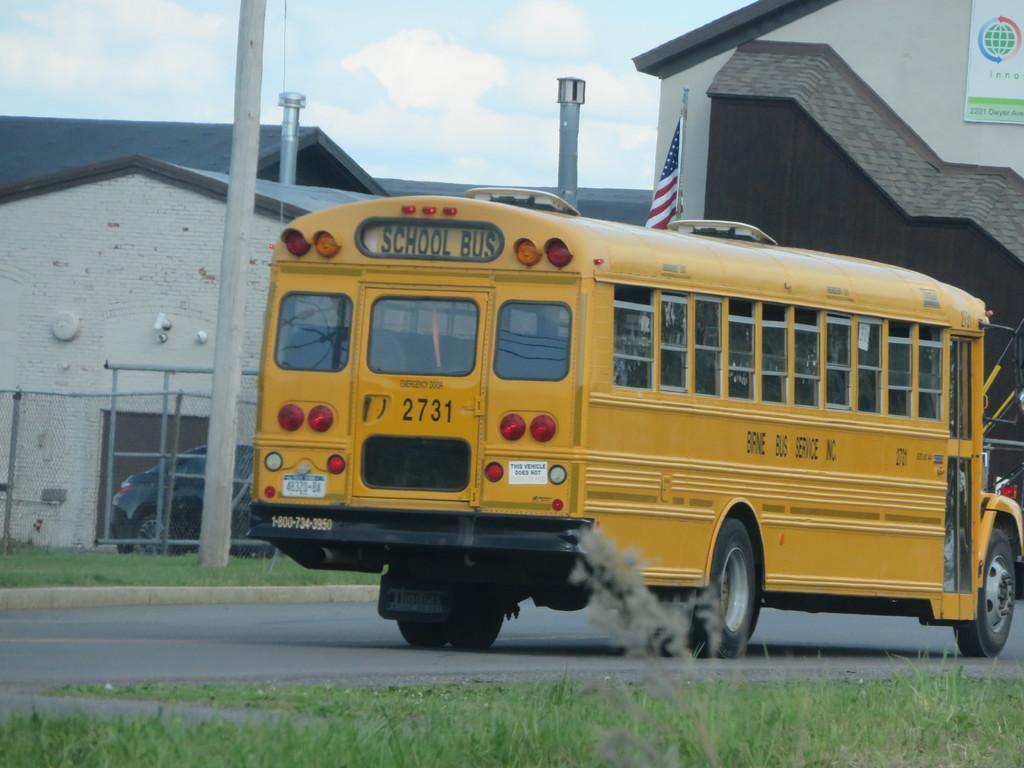Could you give a brief overview of what you see in this image? This image consists of a school bus in yellow color. At the bottom, there is road and green grass. In the background, there are buildings along with poles and chimneys. Behind the bus there is a flag. 